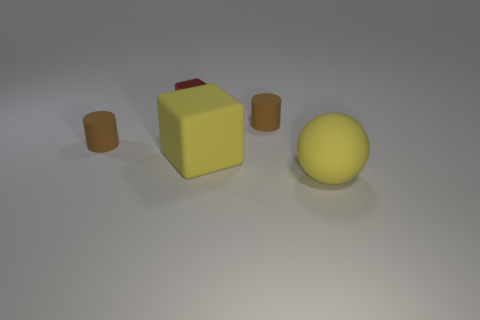Add 1 big cyan matte spheres. How many objects exist? 6 Subtract all red blocks. How many blocks are left? 1 Add 3 rubber cylinders. How many rubber cylinders are left? 5 Add 2 yellow rubber blocks. How many yellow rubber blocks exist? 3 Subtract 0 green cylinders. How many objects are left? 5 Subtract all cylinders. How many objects are left? 3 Subtract 1 spheres. How many spheres are left? 0 Subtract all red cubes. Subtract all red spheres. How many cubes are left? 1 Subtract all green blocks. How many gray cylinders are left? 0 Subtract all yellow rubber spheres. Subtract all small purple things. How many objects are left? 4 